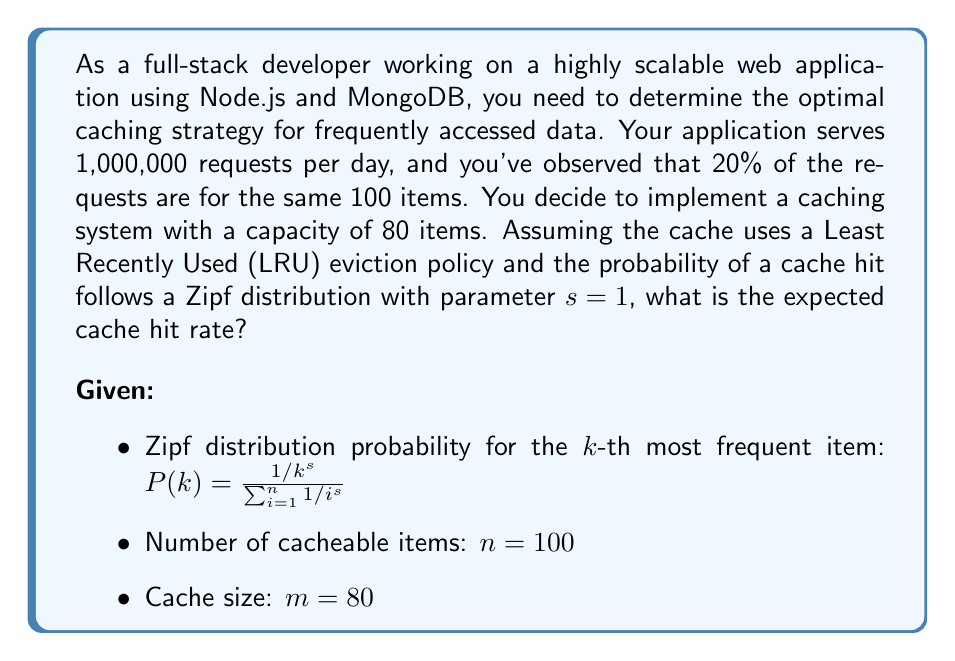Help me with this question. To solve this problem, we need to follow these steps:

1. Calculate the normalization constant for the Zipf distribution.
2. Calculate the probability of each item being requested.
3. Calculate the expected cache hit rate.

Step 1: Calculate the normalization constant

The normalization constant is the sum of the denominators in the Zipf distribution:

$$C = \sum_{i=1}^n \frac{1}{i^s} = \sum_{i=1}^{100} \frac{1}{i^1} = 5.1873$$

Step 2: Calculate the probability of each item being requested

For each item $k$ from 1 to 100, we calculate its probability:

$$P(k) = \frac{1/k^s}{C} = \frac{1/k}{5.1873}$$

Step 3: Calculate the expected cache hit rate

The expected cache hit rate is the sum of the probabilities of the first 80 items (since our cache can hold 80 items):

$$\text{Hit Rate} = \sum_{k=1}^{80} P(k) = \sum_{k=1}^{80} \frac{1}{5.1873k}$$

We can calculate this sum:

$$\text{Hit Rate} = \frac{1}{5.1873} \sum_{k=1}^{80} \frac{1}{k} = \frac{4.7747}{5.1873} \approx 0.9205$$

Therefore, the expected cache hit rate is approximately 92.05%.
Answer: The expected cache hit rate is approximately 92.05%. 